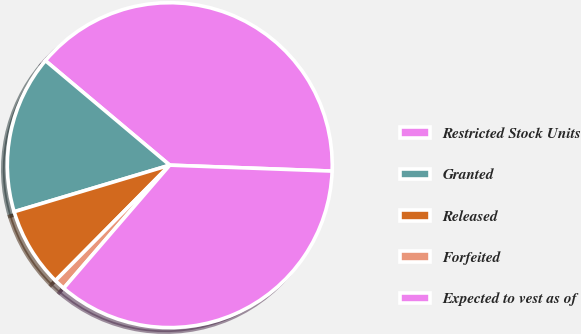Convert chart to OTSL. <chart><loc_0><loc_0><loc_500><loc_500><pie_chart><fcel>Restricted Stock Units<fcel>Granted<fcel>Released<fcel>Forfeited<fcel>Expected to vest as of<nl><fcel>39.46%<fcel>15.75%<fcel>7.95%<fcel>1.1%<fcel>35.74%<nl></chart> 